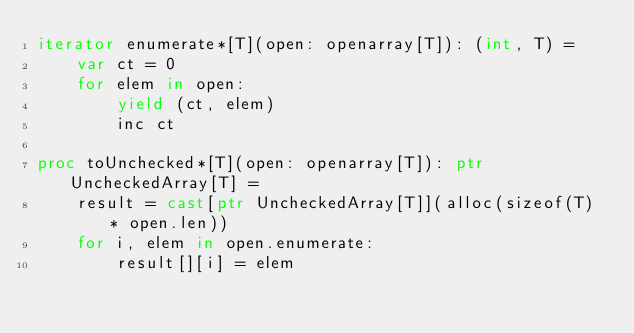<code> <loc_0><loc_0><loc_500><loc_500><_Nim_>iterator enumerate*[T](open: openarray[T]): (int, T) =
    var ct = 0
    for elem in open:
        yield (ct, elem)
        inc ct

proc toUnchecked*[T](open: openarray[T]): ptr UncheckedArray[T] =
    result = cast[ptr UncheckedArray[T]](alloc(sizeof(T) * open.len))
    for i, elem in open.enumerate:
        result[][i] = elem


</code> 